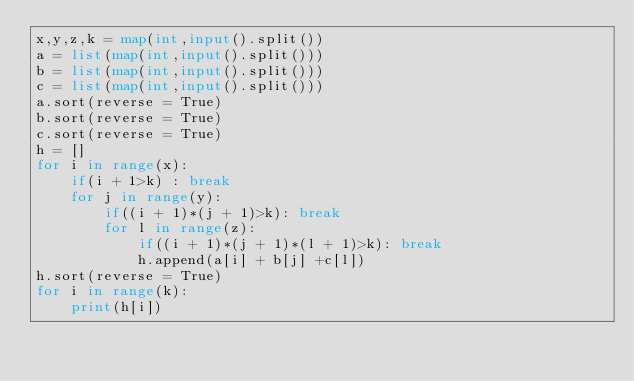Convert code to text. <code><loc_0><loc_0><loc_500><loc_500><_Python_>x,y,z,k = map(int,input().split())
a = list(map(int,input().split()))
b = list(map(int,input().split()))
c = list(map(int,input().split()))
a.sort(reverse = True)
b.sort(reverse = True)
c.sort(reverse = True)
h = []
for i in range(x):
    if(i + 1>k) : break
    for j in range(y):
        if((i + 1)*(j + 1)>k): break
        for l in range(z):
            if((i + 1)*(j + 1)*(l + 1)>k): break
            h.append(a[i] + b[j] +c[l])
h.sort(reverse = True)
for i in range(k):
    print(h[i])</code> 